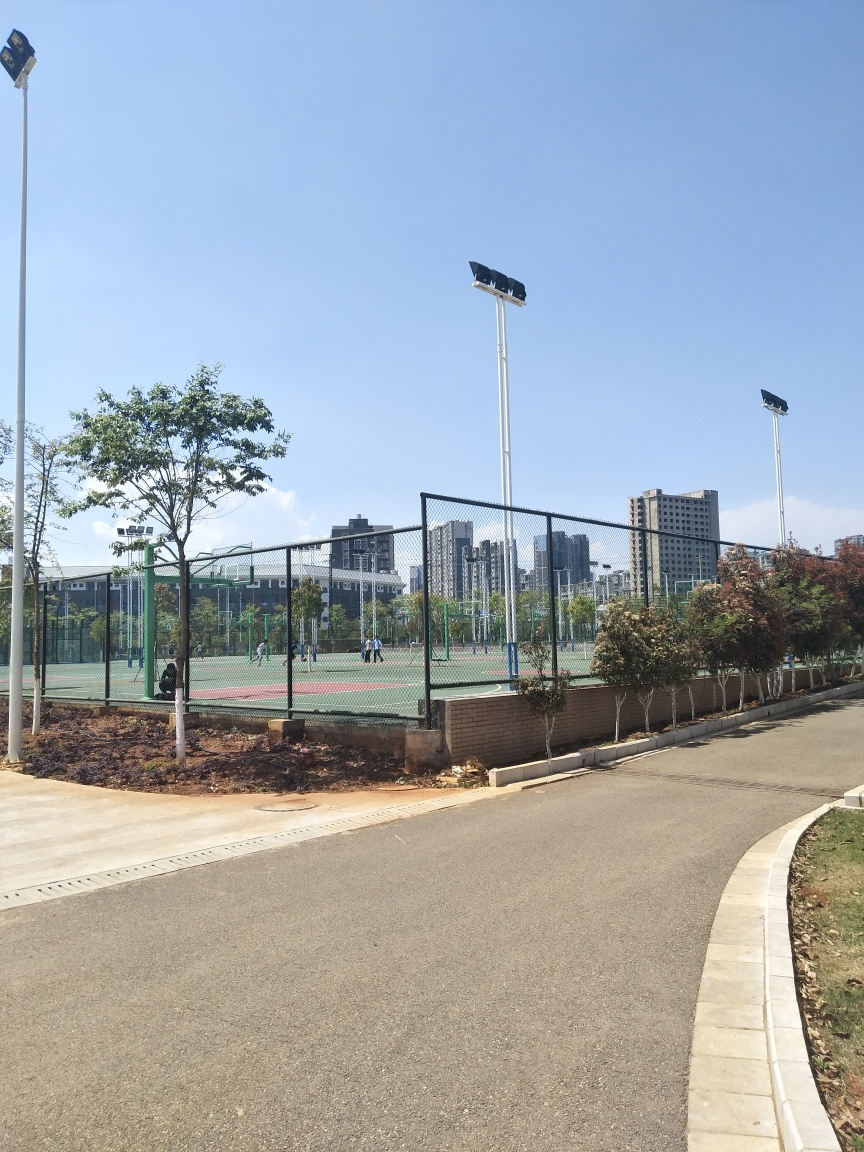Does the image appear clear and bright? Yes, the image shows a bright and clear day, the blue sky is visible, and the sunlight illuminates the outdoor sports courts, pathway, and greenery effectively. 